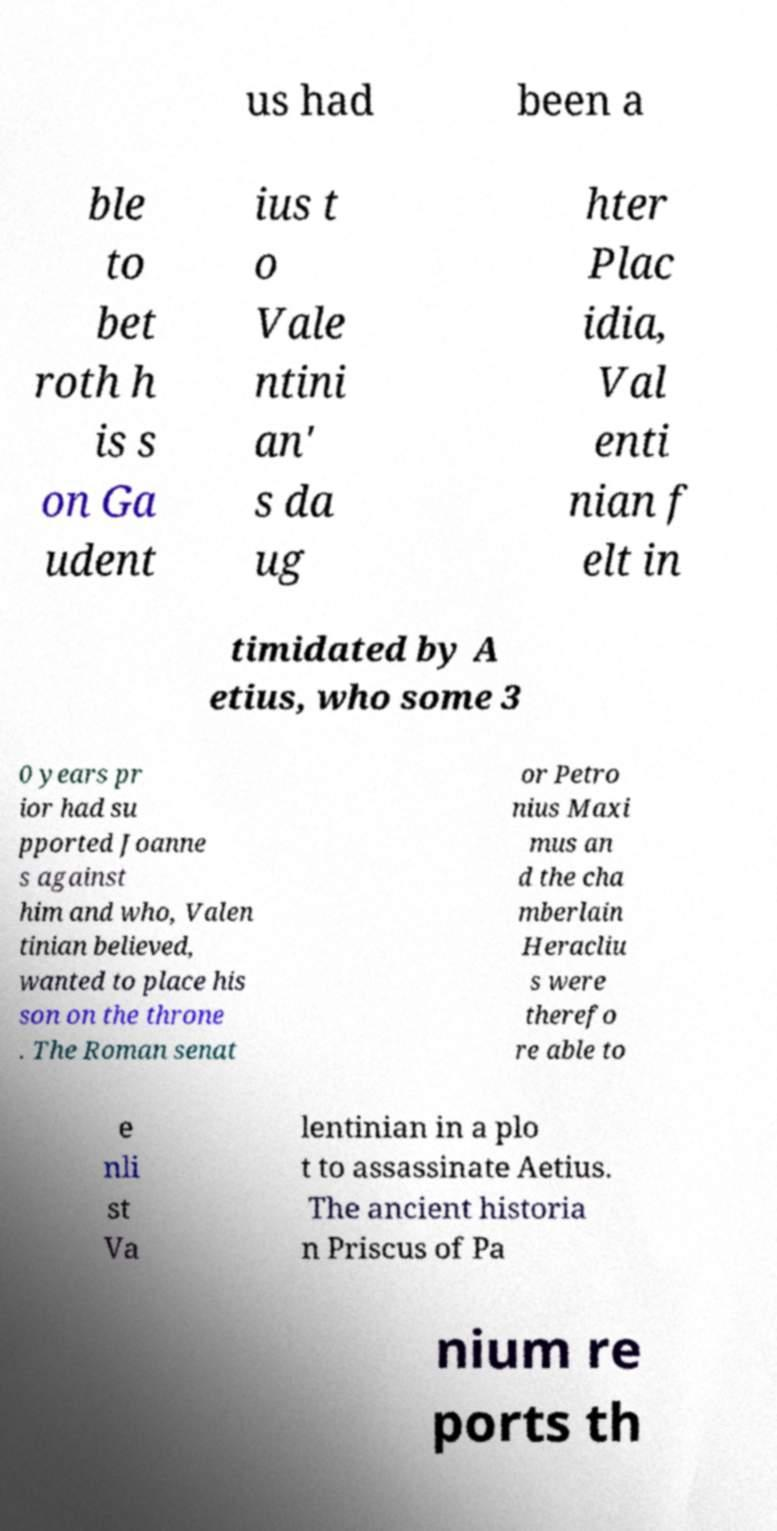Please read and relay the text visible in this image. What does it say? us had been a ble to bet roth h is s on Ga udent ius t o Vale ntini an' s da ug hter Plac idia, Val enti nian f elt in timidated by A etius, who some 3 0 years pr ior had su pported Joanne s against him and who, Valen tinian believed, wanted to place his son on the throne . The Roman senat or Petro nius Maxi mus an d the cha mberlain Heracliu s were therefo re able to e nli st Va lentinian in a plo t to assassinate Aetius. The ancient historia n Priscus of Pa nium re ports th 